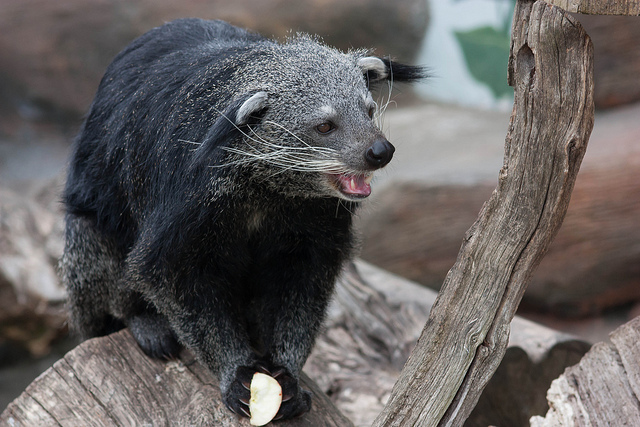<image>What is this animal? I don't know what this animal is. It could be a wolverine, binturong, mongoose, possum, bear, or badger. What is this animal? I don't know what animal this is. It can be seen as a wolverine, binturong, mongoose, possum, bear, or badger. 